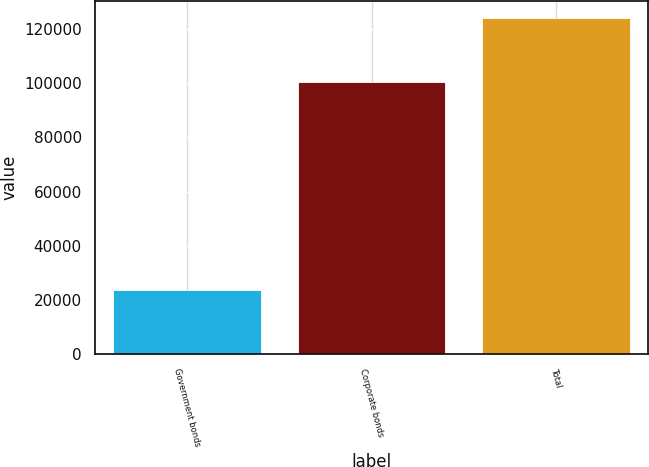Convert chart to OTSL. <chart><loc_0><loc_0><loc_500><loc_500><bar_chart><fcel>Government bonds<fcel>Corporate bonds<fcel>Total<nl><fcel>23717<fcel>100398<fcel>124115<nl></chart> 